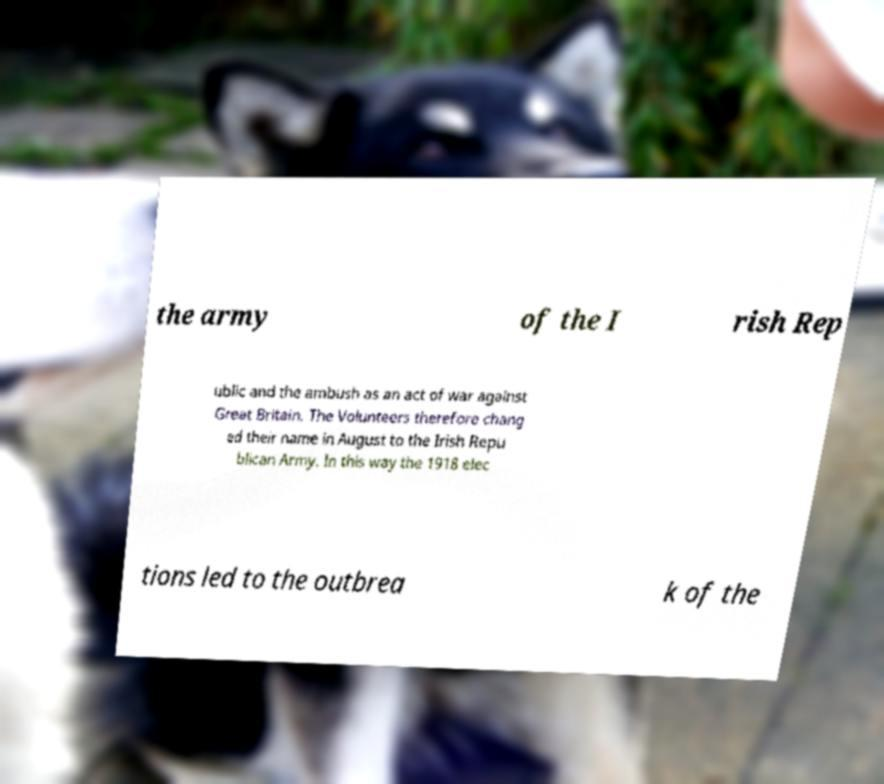I need the written content from this picture converted into text. Can you do that? the army of the I rish Rep ublic and the ambush as an act of war against Great Britain. The Volunteers therefore chang ed their name in August to the Irish Repu blican Army. In this way the 1918 elec tions led to the outbrea k of the 